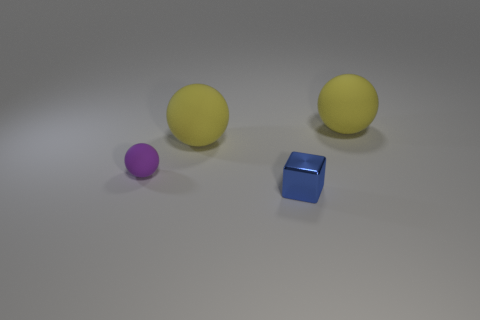Subtract all big yellow balls. How many balls are left? 1 Subtract all purple blocks. How many yellow balls are left? 2 Add 1 small blue metallic cubes. How many objects exist? 5 Subtract all cubes. How many objects are left? 3 Subtract all green balls. Subtract all red cubes. How many balls are left? 3 Add 4 purple matte balls. How many purple matte balls exist? 5 Subtract 2 yellow spheres. How many objects are left? 2 Subtract all purple things. Subtract all tiny purple balls. How many objects are left? 2 Add 1 metal objects. How many metal objects are left? 2 